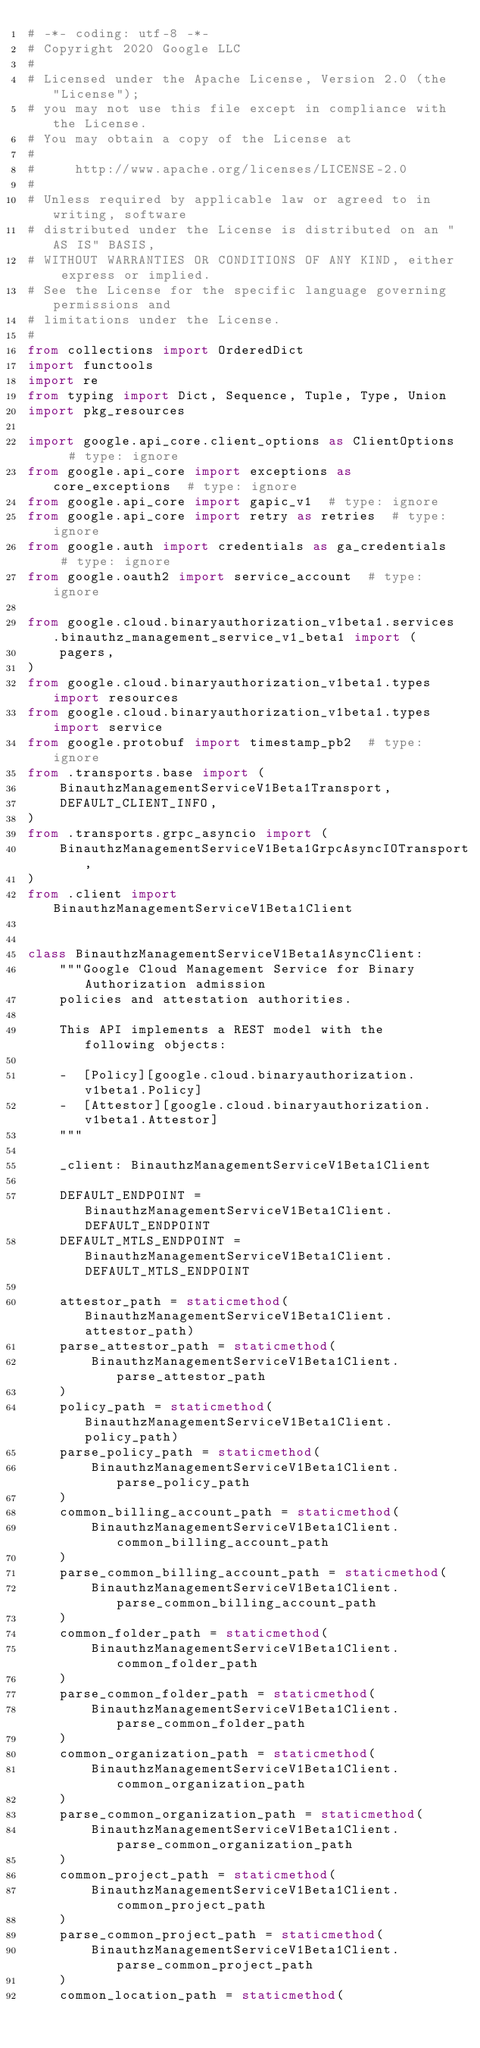<code> <loc_0><loc_0><loc_500><loc_500><_Python_># -*- coding: utf-8 -*-
# Copyright 2020 Google LLC
#
# Licensed under the Apache License, Version 2.0 (the "License");
# you may not use this file except in compliance with the License.
# You may obtain a copy of the License at
#
#     http://www.apache.org/licenses/LICENSE-2.0
#
# Unless required by applicable law or agreed to in writing, software
# distributed under the License is distributed on an "AS IS" BASIS,
# WITHOUT WARRANTIES OR CONDITIONS OF ANY KIND, either express or implied.
# See the License for the specific language governing permissions and
# limitations under the License.
#
from collections import OrderedDict
import functools
import re
from typing import Dict, Sequence, Tuple, Type, Union
import pkg_resources

import google.api_core.client_options as ClientOptions  # type: ignore
from google.api_core import exceptions as core_exceptions  # type: ignore
from google.api_core import gapic_v1  # type: ignore
from google.api_core import retry as retries  # type: ignore
from google.auth import credentials as ga_credentials  # type: ignore
from google.oauth2 import service_account  # type: ignore

from google.cloud.binaryauthorization_v1beta1.services.binauthz_management_service_v1_beta1 import (
    pagers,
)
from google.cloud.binaryauthorization_v1beta1.types import resources
from google.cloud.binaryauthorization_v1beta1.types import service
from google.protobuf import timestamp_pb2  # type: ignore
from .transports.base import (
    BinauthzManagementServiceV1Beta1Transport,
    DEFAULT_CLIENT_INFO,
)
from .transports.grpc_asyncio import (
    BinauthzManagementServiceV1Beta1GrpcAsyncIOTransport,
)
from .client import BinauthzManagementServiceV1Beta1Client


class BinauthzManagementServiceV1Beta1AsyncClient:
    """Google Cloud Management Service for Binary Authorization admission
    policies and attestation authorities.

    This API implements a REST model with the following objects:

    -  [Policy][google.cloud.binaryauthorization.v1beta1.Policy]
    -  [Attestor][google.cloud.binaryauthorization.v1beta1.Attestor]
    """

    _client: BinauthzManagementServiceV1Beta1Client

    DEFAULT_ENDPOINT = BinauthzManagementServiceV1Beta1Client.DEFAULT_ENDPOINT
    DEFAULT_MTLS_ENDPOINT = BinauthzManagementServiceV1Beta1Client.DEFAULT_MTLS_ENDPOINT

    attestor_path = staticmethod(BinauthzManagementServiceV1Beta1Client.attestor_path)
    parse_attestor_path = staticmethod(
        BinauthzManagementServiceV1Beta1Client.parse_attestor_path
    )
    policy_path = staticmethod(BinauthzManagementServiceV1Beta1Client.policy_path)
    parse_policy_path = staticmethod(
        BinauthzManagementServiceV1Beta1Client.parse_policy_path
    )
    common_billing_account_path = staticmethod(
        BinauthzManagementServiceV1Beta1Client.common_billing_account_path
    )
    parse_common_billing_account_path = staticmethod(
        BinauthzManagementServiceV1Beta1Client.parse_common_billing_account_path
    )
    common_folder_path = staticmethod(
        BinauthzManagementServiceV1Beta1Client.common_folder_path
    )
    parse_common_folder_path = staticmethod(
        BinauthzManagementServiceV1Beta1Client.parse_common_folder_path
    )
    common_organization_path = staticmethod(
        BinauthzManagementServiceV1Beta1Client.common_organization_path
    )
    parse_common_organization_path = staticmethod(
        BinauthzManagementServiceV1Beta1Client.parse_common_organization_path
    )
    common_project_path = staticmethod(
        BinauthzManagementServiceV1Beta1Client.common_project_path
    )
    parse_common_project_path = staticmethod(
        BinauthzManagementServiceV1Beta1Client.parse_common_project_path
    )
    common_location_path = staticmethod(</code> 